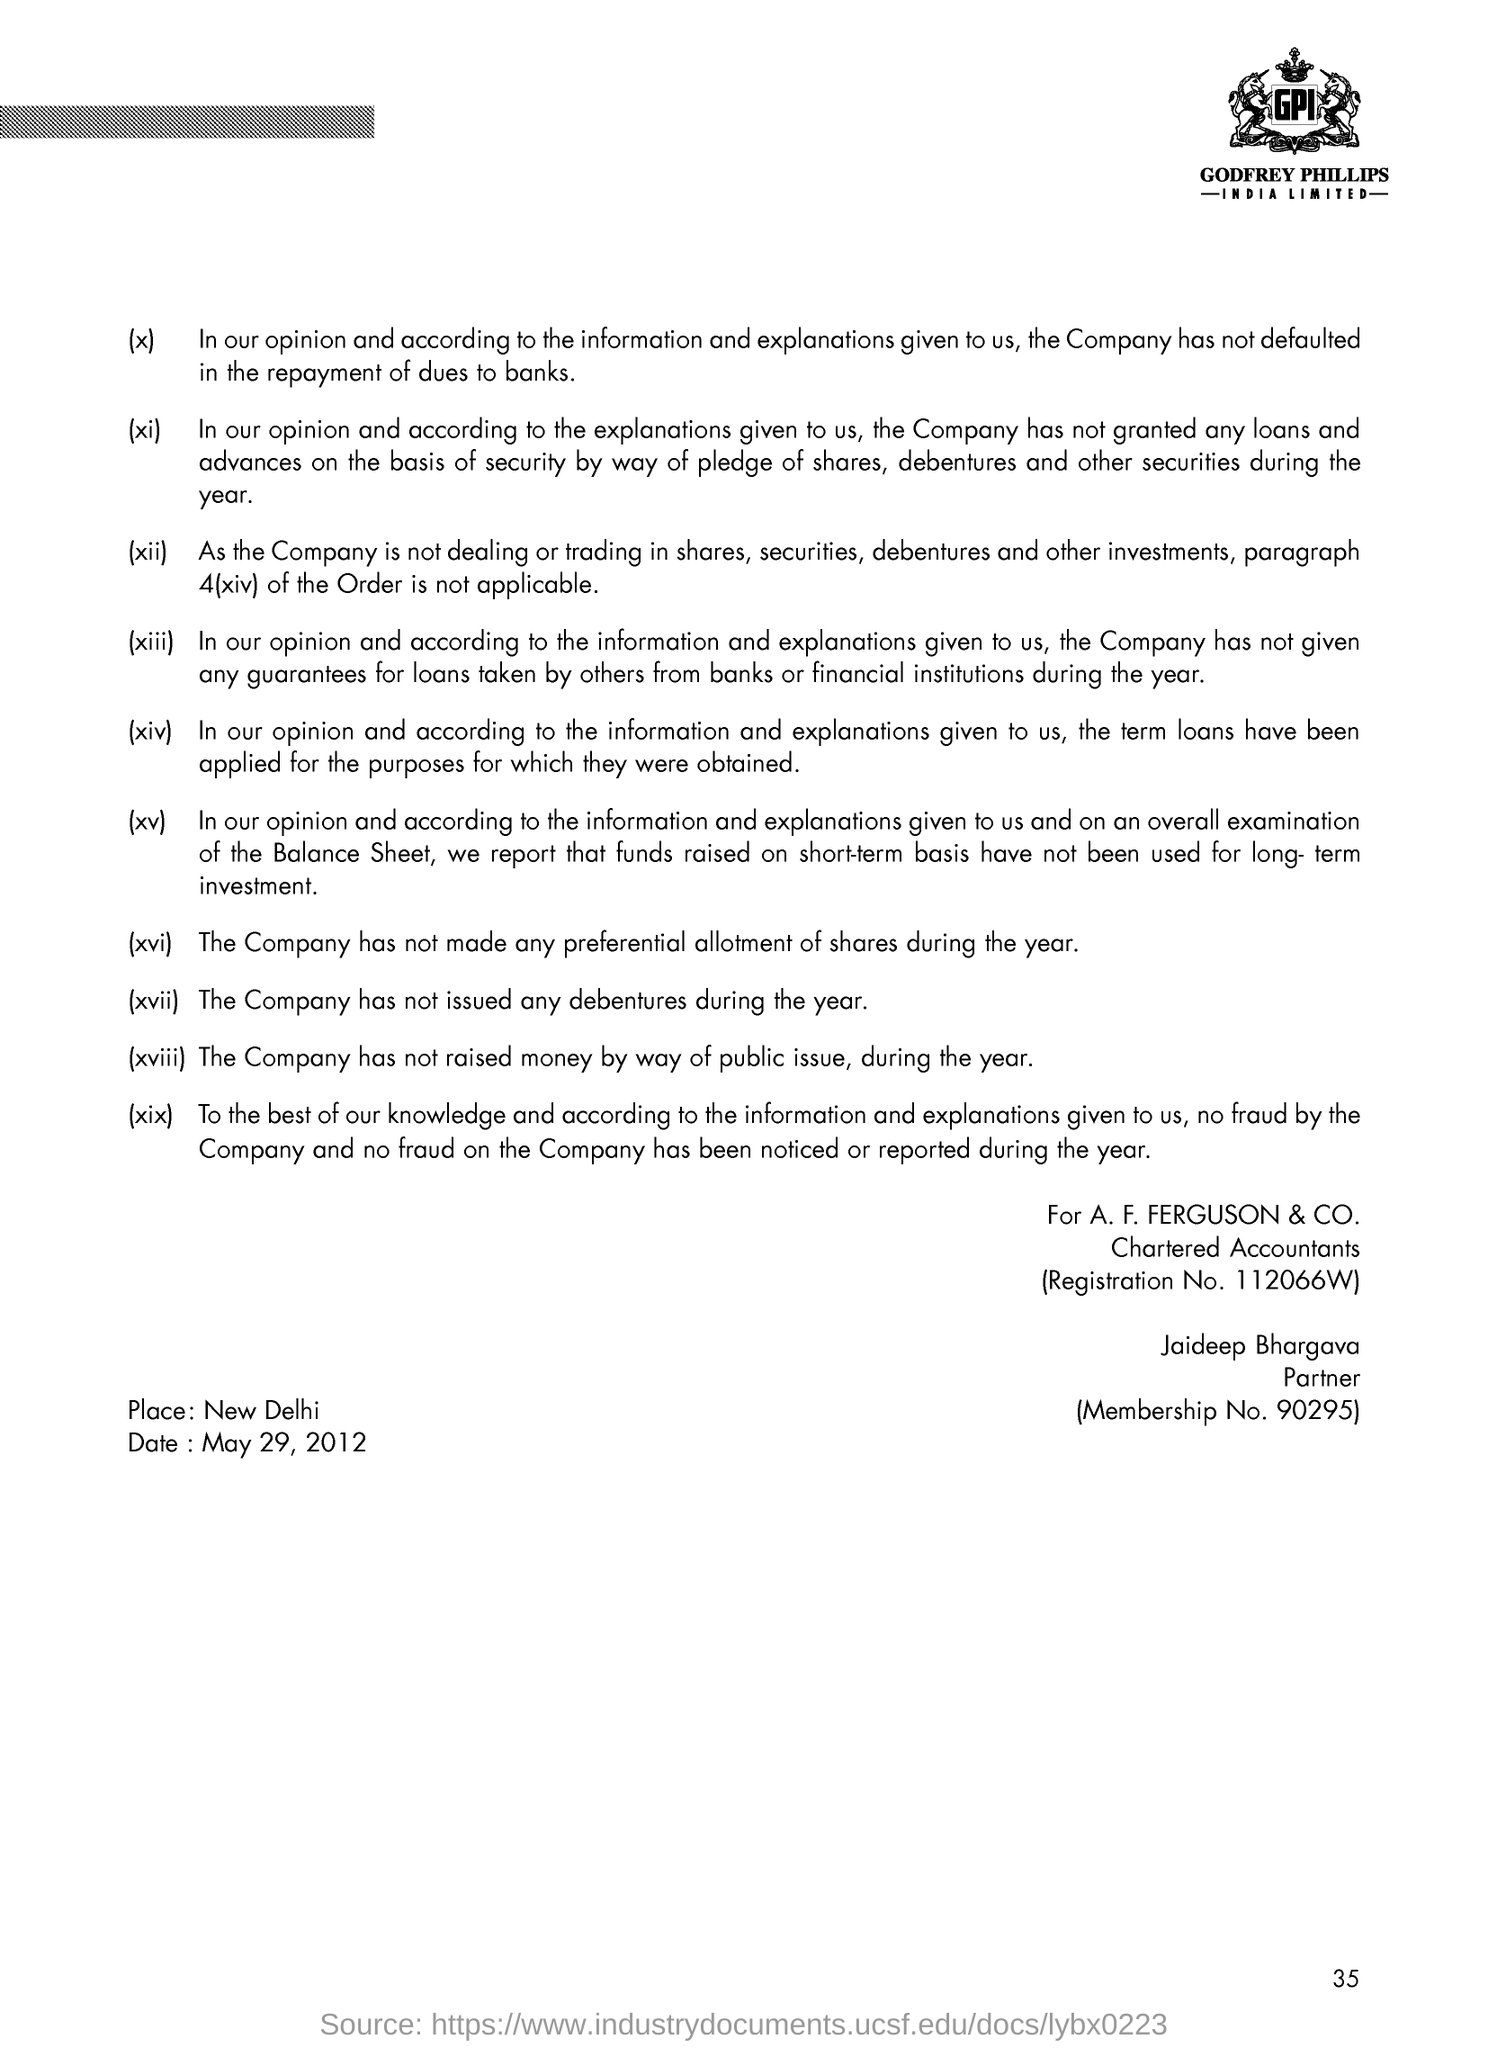What is the Registration No. of the Chartered Accountants?
Ensure brevity in your answer.  112066W. What is the designation of Jaideep Bhargava?
Offer a very short reply. Partner. When is the document dated?
Offer a terse response. May 29, 2012. What is the Membership No. of Jaideep Bhargava?
Offer a very short reply. 90295. 